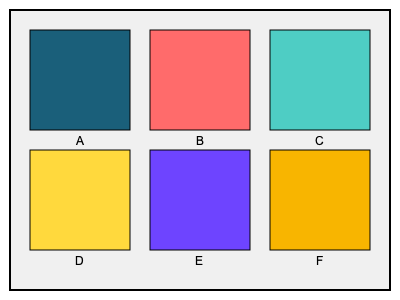Which color scheme would be most effective for a 3D architectural model to capture investor attention, considering principles of color theory and visual impact? To determine the most visually striking color scheme for a 3D architectural model, we need to consider several factors:

1. Color harmony: Complementary or analogous colors create visually appealing combinations.
2. Contrast: High contrast between colors can create a bold, eye-catching effect.
3. Saturation: Vibrant colors tend to be more attention-grabbing.
4. Psychological impact: Certain colors evoke specific emotions or associations.
5. Context: The color scheme should be appropriate for architectural presentation.

Let's analyze each option:

A. Navy blue and teal: Creates a professional, calming effect but lacks vibrancy.
B. Coral red and light blue: High contrast and complementary colors, energetic and modern.
C. Teal and mint green: Analogous colors, soothing but may lack impact.
D. Yellow and navy blue: High contrast and complementary, bold and attention-grabbing.
E. Deep purple and light purple: Monochromatic, elegant but may lack variety.
F. Orange and yellow: Analogous colors, warm and energetic but may be too intense.

Option D (Yellow and navy blue) stands out as the most effective choice because:
1. It offers high contrast, making it visually striking.
2. The colors are complementary, creating a harmonious yet impactful combination.
3. Yellow is associated with energy and optimism, while navy blue conveys trust and professionalism.
4. This combination is bold enough to capture attention without being overwhelming.
5. It's suitable for architectural presentations, as it can highlight both warm and cool elements of a design.
Answer: D (Yellow and navy blue) 